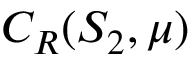Convert formula to latex. <formula><loc_0><loc_0><loc_500><loc_500>C _ { R } ( S _ { 2 } , \mu )</formula> 